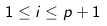<formula> <loc_0><loc_0><loc_500><loc_500>1 \leq i \leq p + 1</formula> 